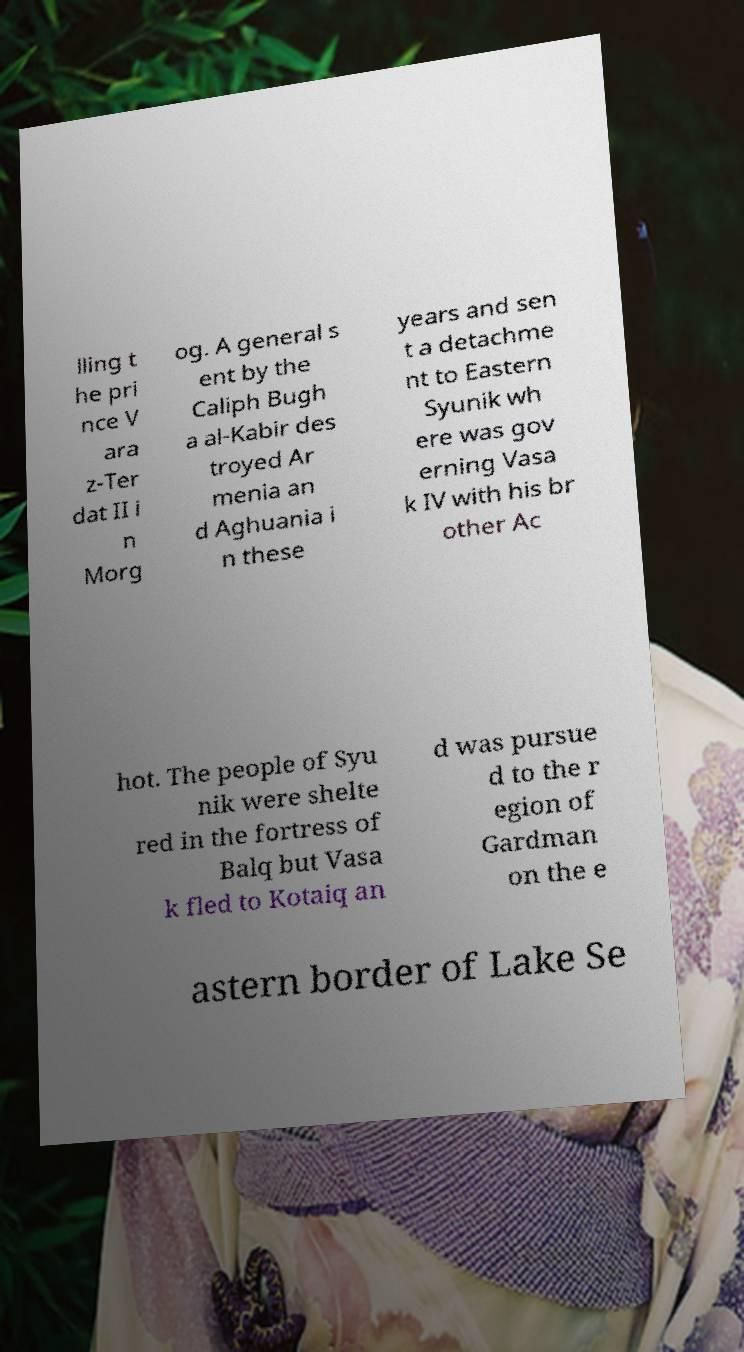Could you extract and type out the text from this image? lling t he pri nce V ara z-Ter dat II i n Morg og. A general s ent by the Caliph Bugh a al-Kabir des troyed Ar menia an d Aghuania i n these years and sen t a detachme nt to Eastern Syunik wh ere was gov erning Vasa k IV with his br other Ac hot. The people of Syu nik were shelte red in the fortress of Balq but Vasa k fled to Kotaiq an d was pursue d to the r egion of Gardman on the e astern border of Lake Se 